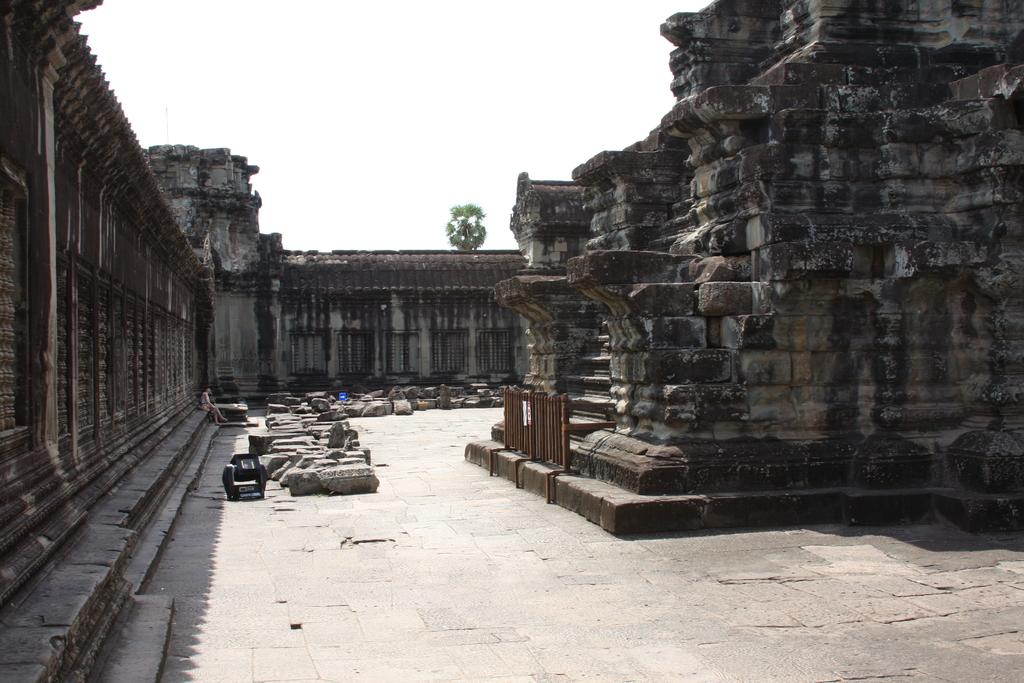What type of structures are made with rocks in the image? There are constructions made with rocks in the image. What else can be seen on the floor in the image? Rocks are visible on the floor in the image. Can you describe the person on the left side of the image? There appears to be a person on the left side of the image, but their appearance or actions cannot be determined from the provided facts. What is visible in the background of the image? There is a tree in the background of the image. How many wrens are perched on the rocks in the image? There is no mention of wrens in the provided facts, so it cannot be determined if any are present in the image. What type of tools does the carpenter use to build the rock constructions in the image? There is no mention of a carpenter or any tools in the provided facts, so it cannot be determined what tools might be used to build the rock constructions. 